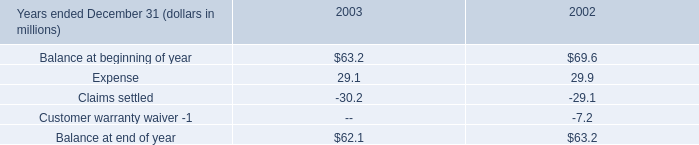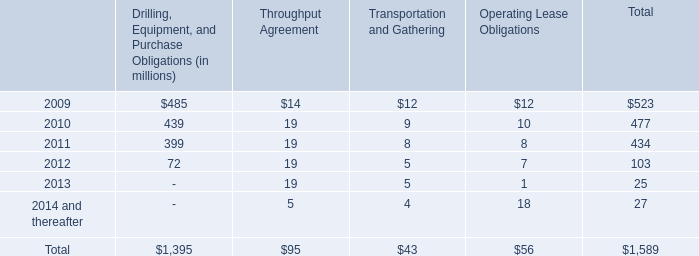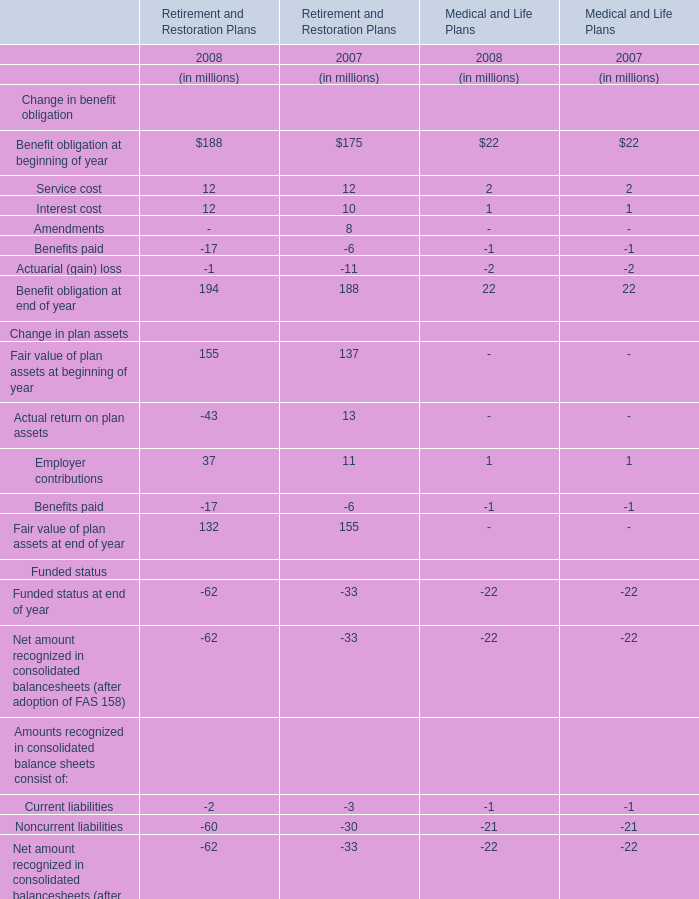Does the average value of Interest cost for Retirement and Restoration Plans in 2008 greater than that in 2007? 
Answer: yes. 